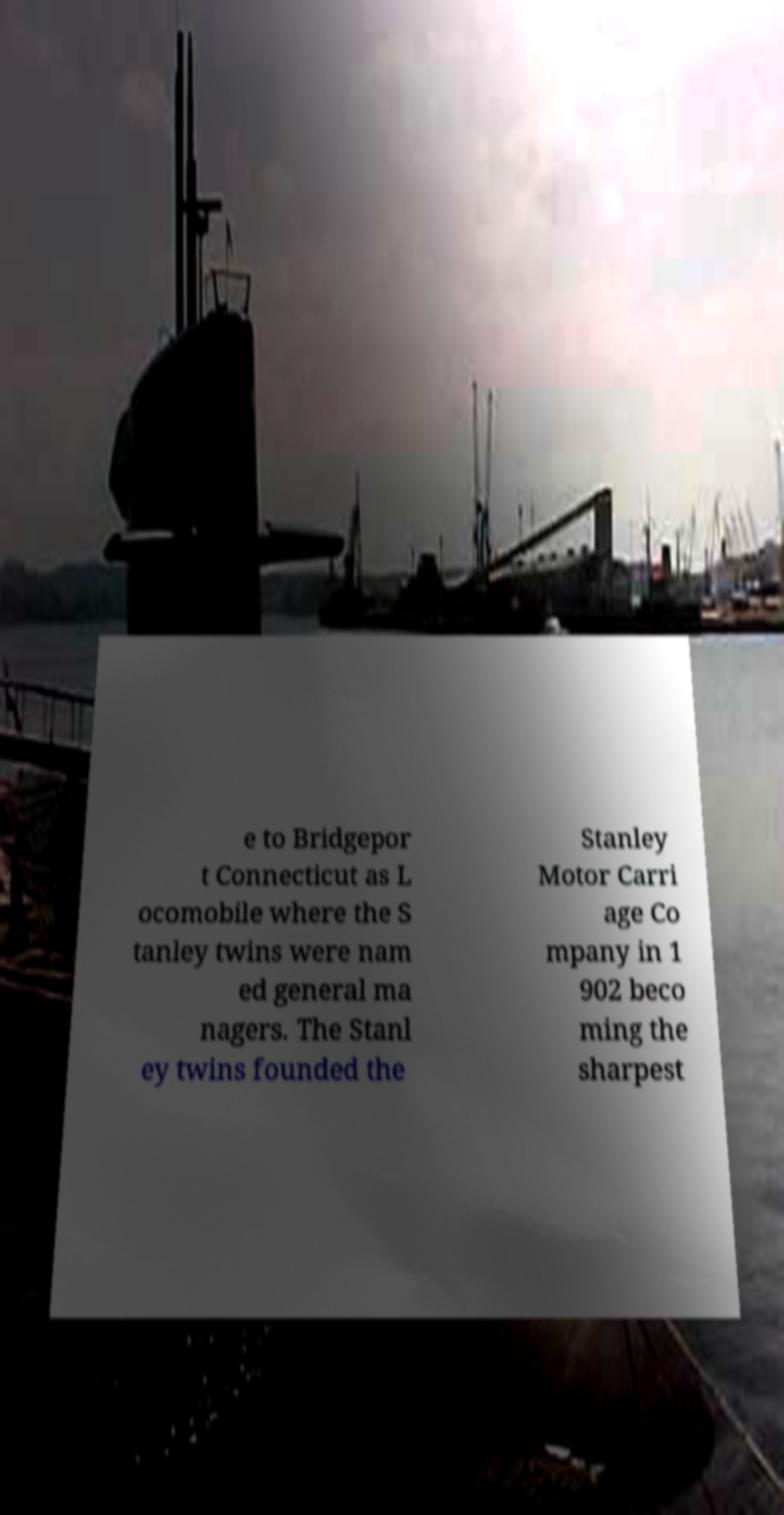What messages or text are displayed in this image? I need them in a readable, typed format. e to Bridgepor t Connecticut as L ocomobile where the S tanley twins were nam ed general ma nagers. The Stanl ey twins founded the Stanley Motor Carri age Co mpany in 1 902 beco ming the sharpest 